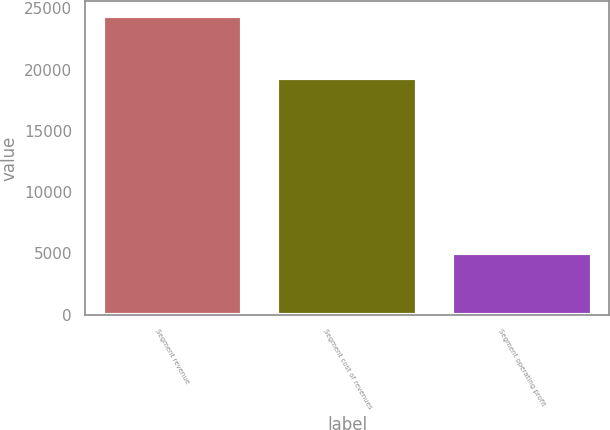Convert chart. <chart><loc_0><loc_0><loc_500><loc_500><bar_chart><fcel>Segment revenue<fcel>Segment cost of revenues<fcel>Segment operating profit<nl><fcel>24349<fcel>19295<fcel>5054<nl></chart> 